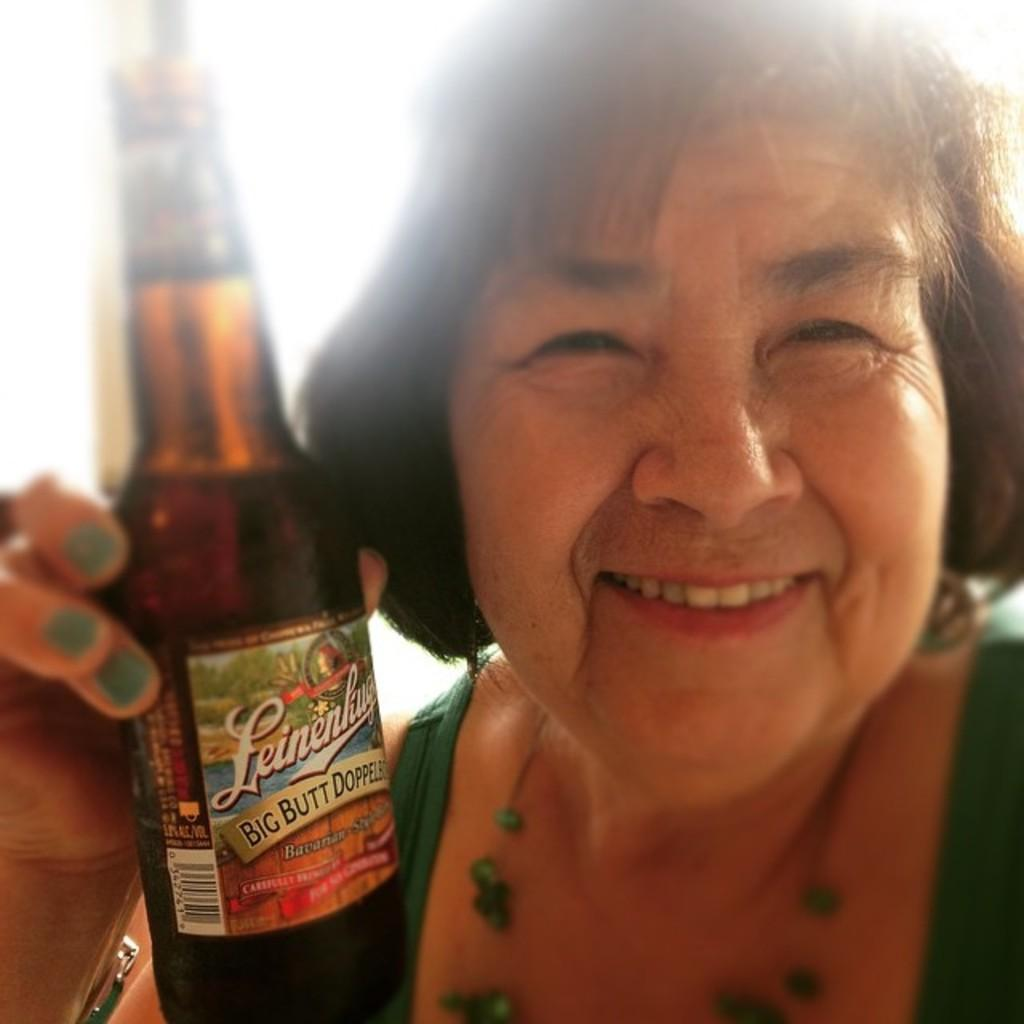Who is the main subject in the image? There is a woman in the image. What is the woman doing in the image? The woman is smiling in the image. What object is the woman holding in her hand? The woman is holding a bottle in her hand. What type of bean is visible in the woman's hand in the image? There is no bean visible in the woman's hand in the image; she is holding a bottle. 